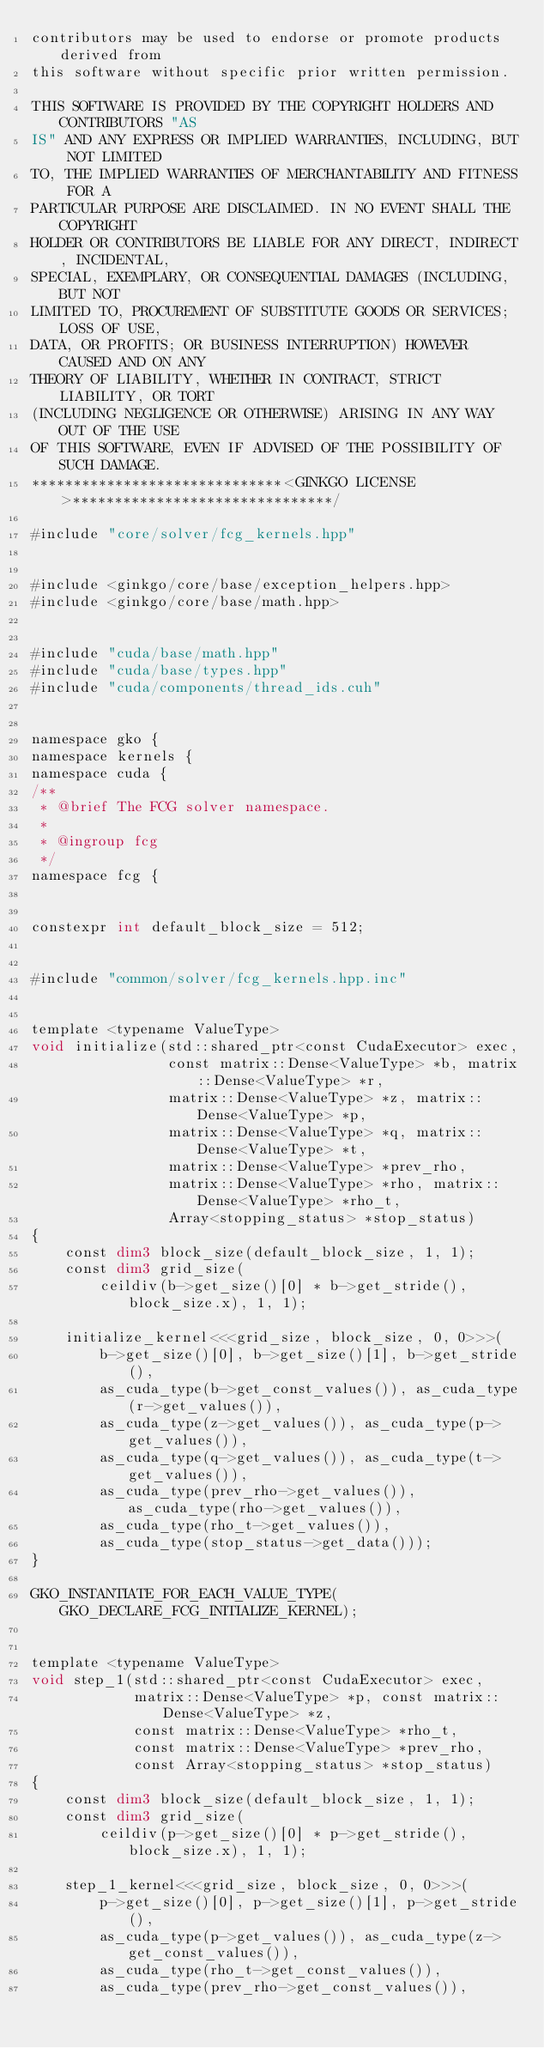<code> <loc_0><loc_0><loc_500><loc_500><_Cuda_>contributors may be used to endorse or promote products derived from
this software without specific prior written permission.

THIS SOFTWARE IS PROVIDED BY THE COPYRIGHT HOLDERS AND CONTRIBUTORS "AS
IS" AND ANY EXPRESS OR IMPLIED WARRANTIES, INCLUDING, BUT NOT LIMITED
TO, THE IMPLIED WARRANTIES OF MERCHANTABILITY AND FITNESS FOR A
PARTICULAR PURPOSE ARE DISCLAIMED. IN NO EVENT SHALL THE COPYRIGHT
HOLDER OR CONTRIBUTORS BE LIABLE FOR ANY DIRECT, INDIRECT, INCIDENTAL,
SPECIAL, EXEMPLARY, OR CONSEQUENTIAL DAMAGES (INCLUDING, BUT NOT
LIMITED TO, PROCUREMENT OF SUBSTITUTE GOODS OR SERVICES; LOSS OF USE,
DATA, OR PROFITS; OR BUSINESS INTERRUPTION) HOWEVER CAUSED AND ON ANY
THEORY OF LIABILITY, WHETHER IN CONTRACT, STRICT LIABILITY, OR TORT
(INCLUDING NEGLIGENCE OR OTHERWISE) ARISING IN ANY WAY OUT OF THE USE
OF THIS SOFTWARE, EVEN IF ADVISED OF THE POSSIBILITY OF SUCH DAMAGE.
******************************<GINKGO LICENSE>*******************************/

#include "core/solver/fcg_kernels.hpp"


#include <ginkgo/core/base/exception_helpers.hpp>
#include <ginkgo/core/base/math.hpp>


#include "cuda/base/math.hpp"
#include "cuda/base/types.hpp"
#include "cuda/components/thread_ids.cuh"


namespace gko {
namespace kernels {
namespace cuda {
/**
 * @brief The FCG solver namespace.
 *
 * @ingroup fcg
 */
namespace fcg {


constexpr int default_block_size = 512;


#include "common/solver/fcg_kernels.hpp.inc"


template <typename ValueType>
void initialize(std::shared_ptr<const CudaExecutor> exec,
                const matrix::Dense<ValueType> *b, matrix::Dense<ValueType> *r,
                matrix::Dense<ValueType> *z, matrix::Dense<ValueType> *p,
                matrix::Dense<ValueType> *q, matrix::Dense<ValueType> *t,
                matrix::Dense<ValueType> *prev_rho,
                matrix::Dense<ValueType> *rho, matrix::Dense<ValueType> *rho_t,
                Array<stopping_status> *stop_status)
{
    const dim3 block_size(default_block_size, 1, 1);
    const dim3 grid_size(
        ceildiv(b->get_size()[0] * b->get_stride(), block_size.x), 1, 1);

    initialize_kernel<<<grid_size, block_size, 0, 0>>>(
        b->get_size()[0], b->get_size()[1], b->get_stride(),
        as_cuda_type(b->get_const_values()), as_cuda_type(r->get_values()),
        as_cuda_type(z->get_values()), as_cuda_type(p->get_values()),
        as_cuda_type(q->get_values()), as_cuda_type(t->get_values()),
        as_cuda_type(prev_rho->get_values()), as_cuda_type(rho->get_values()),
        as_cuda_type(rho_t->get_values()),
        as_cuda_type(stop_status->get_data()));
}

GKO_INSTANTIATE_FOR_EACH_VALUE_TYPE(GKO_DECLARE_FCG_INITIALIZE_KERNEL);


template <typename ValueType>
void step_1(std::shared_ptr<const CudaExecutor> exec,
            matrix::Dense<ValueType> *p, const matrix::Dense<ValueType> *z,
            const matrix::Dense<ValueType> *rho_t,
            const matrix::Dense<ValueType> *prev_rho,
            const Array<stopping_status> *stop_status)
{
    const dim3 block_size(default_block_size, 1, 1);
    const dim3 grid_size(
        ceildiv(p->get_size()[0] * p->get_stride(), block_size.x), 1, 1);

    step_1_kernel<<<grid_size, block_size, 0, 0>>>(
        p->get_size()[0], p->get_size()[1], p->get_stride(),
        as_cuda_type(p->get_values()), as_cuda_type(z->get_const_values()),
        as_cuda_type(rho_t->get_const_values()),
        as_cuda_type(prev_rho->get_const_values()),</code> 